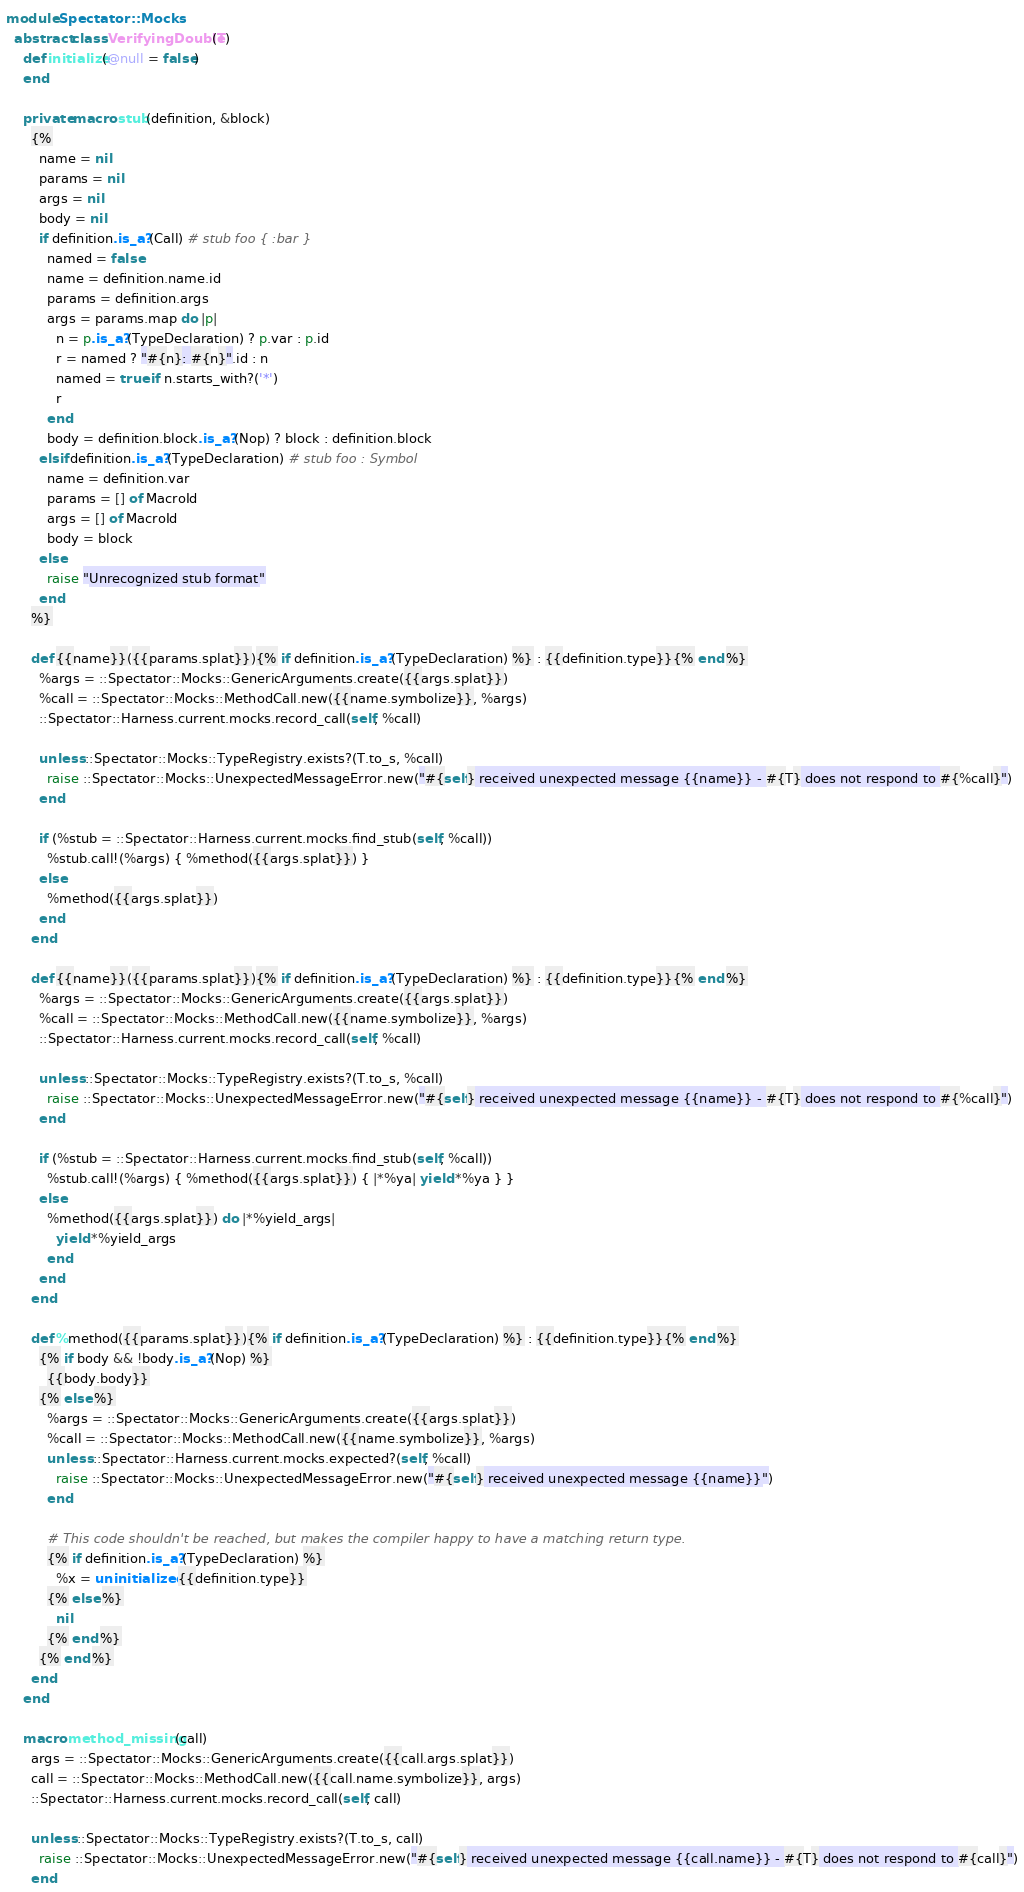Convert code to text. <code><loc_0><loc_0><loc_500><loc_500><_Crystal_>module Spectator::Mocks
  abstract class VerifyingDouble(T)
    def initialize(@null = false)
    end

    private macro stub(definition, &block)
      {%
        name = nil
        params = nil
        args = nil
        body = nil
        if definition.is_a?(Call) # stub foo { :bar }
          named = false
          name = definition.name.id
          params = definition.args
          args = params.map do |p|
            n = p.is_a?(TypeDeclaration) ? p.var : p.id
            r = named ? "#{n}: #{n}".id : n
            named = true if n.starts_with?('*')
            r
          end
          body = definition.block.is_a?(Nop) ? block : definition.block
        elsif definition.is_a?(TypeDeclaration) # stub foo : Symbol
          name = definition.var
          params = [] of MacroId
          args = [] of MacroId
          body = block
        else
          raise "Unrecognized stub format"
        end
      %}

      def {{name}}({{params.splat}}){% if definition.is_a?(TypeDeclaration) %} : {{definition.type}}{% end %}
        %args = ::Spectator::Mocks::GenericArguments.create({{args.splat}})
        %call = ::Spectator::Mocks::MethodCall.new({{name.symbolize}}, %args)
        ::Spectator::Harness.current.mocks.record_call(self, %call)

        unless ::Spectator::Mocks::TypeRegistry.exists?(T.to_s, %call)
          raise ::Spectator::Mocks::UnexpectedMessageError.new("#{self} received unexpected message {{name}} - #{T} does not respond to #{%call}")
        end

        if (%stub = ::Spectator::Harness.current.mocks.find_stub(self, %call))
          %stub.call!(%args) { %method({{args.splat}}) }
        else
          %method({{args.splat}})
        end
      end

      def {{name}}({{params.splat}}){% if definition.is_a?(TypeDeclaration) %} : {{definition.type}}{% end %}
        %args = ::Spectator::Mocks::GenericArguments.create({{args.splat}})
        %call = ::Spectator::Mocks::MethodCall.new({{name.symbolize}}, %args)
        ::Spectator::Harness.current.mocks.record_call(self, %call)

        unless ::Spectator::Mocks::TypeRegistry.exists?(T.to_s, %call)
          raise ::Spectator::Mocks::UnexpectedMessageError.new("#{self} received unexpected message {{name}} - #{T} does not respond to #{%call}")
        end

        if (%stub = ::Spectator::Harness.current.mocks.find_stub(self, %call))
          %stub.call!(%args) { %method({{args.splat}}) { |*%ya| yield *%ya } }
        else
          %method({{args.splat}}) do |*%yield_args|
            yield *%yield_args
          end
        end
      end

      def %method({{params.splat}}){% if definition.is_a?(TypeDeclaration) %} : {{definition.type}}{% end %}
        {% if body && !body.is_a?(Nop) %}
          {{body.body}}
        {% else %}
          %args = ::Spectator::Mocks::GenericArguments.create({{args.splat}})
          %call = ::Spectator::Mocks::MethodCall.new({{name.symbolize}}, %args)
          unless ::Spectator::Harness.current.mocks.expected?(self, %call)
            raise ::Spectator::Mocks::UnexpectedMessageError.new("#{self} received unexpected message {{name}}")
          end

          # This code shouldn't be reached, but makes the compiler happy to have a matching return type.
          {% if definition.is_a?(TypeDeclaration) %}
            %x = uninitialized {{definition.type}}
          {% else %}
            nil
          {% end %}
        {% end %}
      end
    end

    macro method_missing(call)
      args = ::Spectator::Mocks::GenericArguments.create({{call.args.splat}})
      call = ::Spectator::Mocks::MethodCall.new({{call.name.symbolize}}, args)
      ::Spectator::Harness.current.mocks.record_call(self, call)

      unless ::Spectator::Mocks::TypeRegistry.exists?(T.to_s, call)
        raise ::Spectator::Mocks::UnexpectedMessageError.new("#{self} received unexpected message {{call.name}} - #{T} does not respond to #{call}")
      end
</code> 